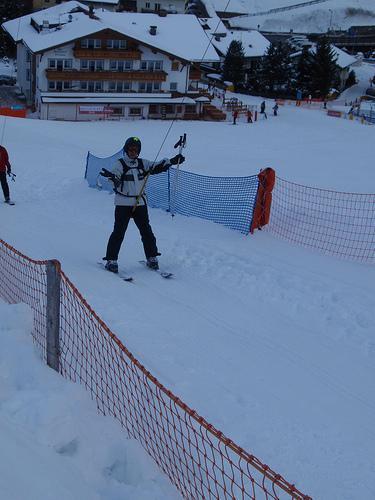How many people are there?
Give a very brief answer. 2. 